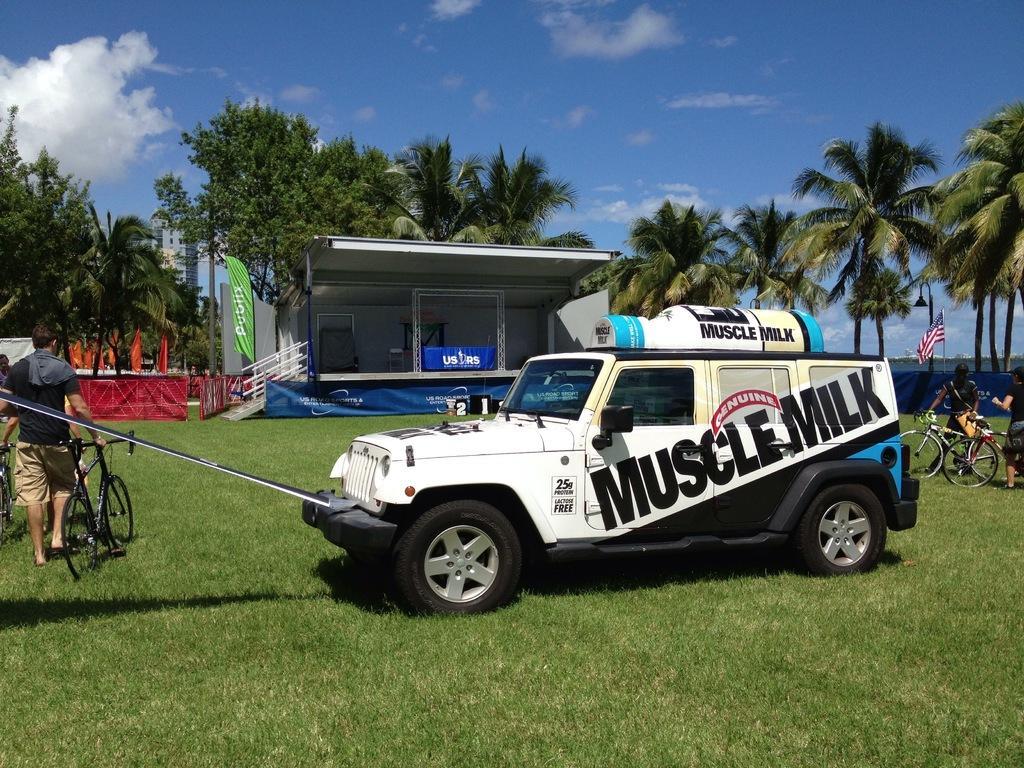Describe this image in one or two sentences. The vehicle which has muscle milk written on it and there are persons walking along with cycles in front and behind the vehicle and the ground is greenery and there are trees in the background. 